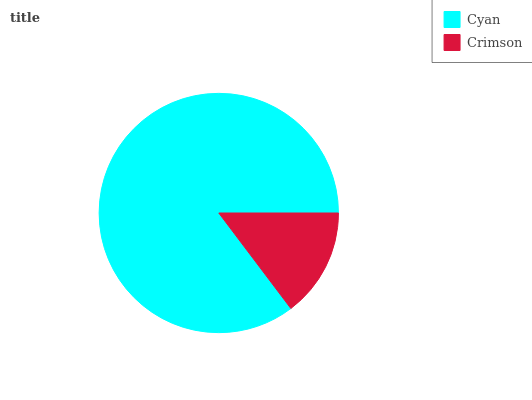Is Crimson the minimum?
Answer yes or no. Yes. Is Cyan the maximum?
Answer yes or no. Yes. Is Crimson the maximum?
Answer yes or no. No. Is Cyan greater than Crimson?
Answer yes or no. Yes. Is Crimson less than Cyan?
Answer yes or no. Yes. Is Crimson greater than Cyan?
Answer yes or no. No. Is Cyan less than Crimson?
Answer yes or no. No. Is Cyan the high median?
Answer yes or no. Yes. Is Crimson the low median?
Answer yes or no. Yes. Is Crimson the high median?
Answer yes or no. No. Is Cyan the low median?
Answer yes or no. No. 